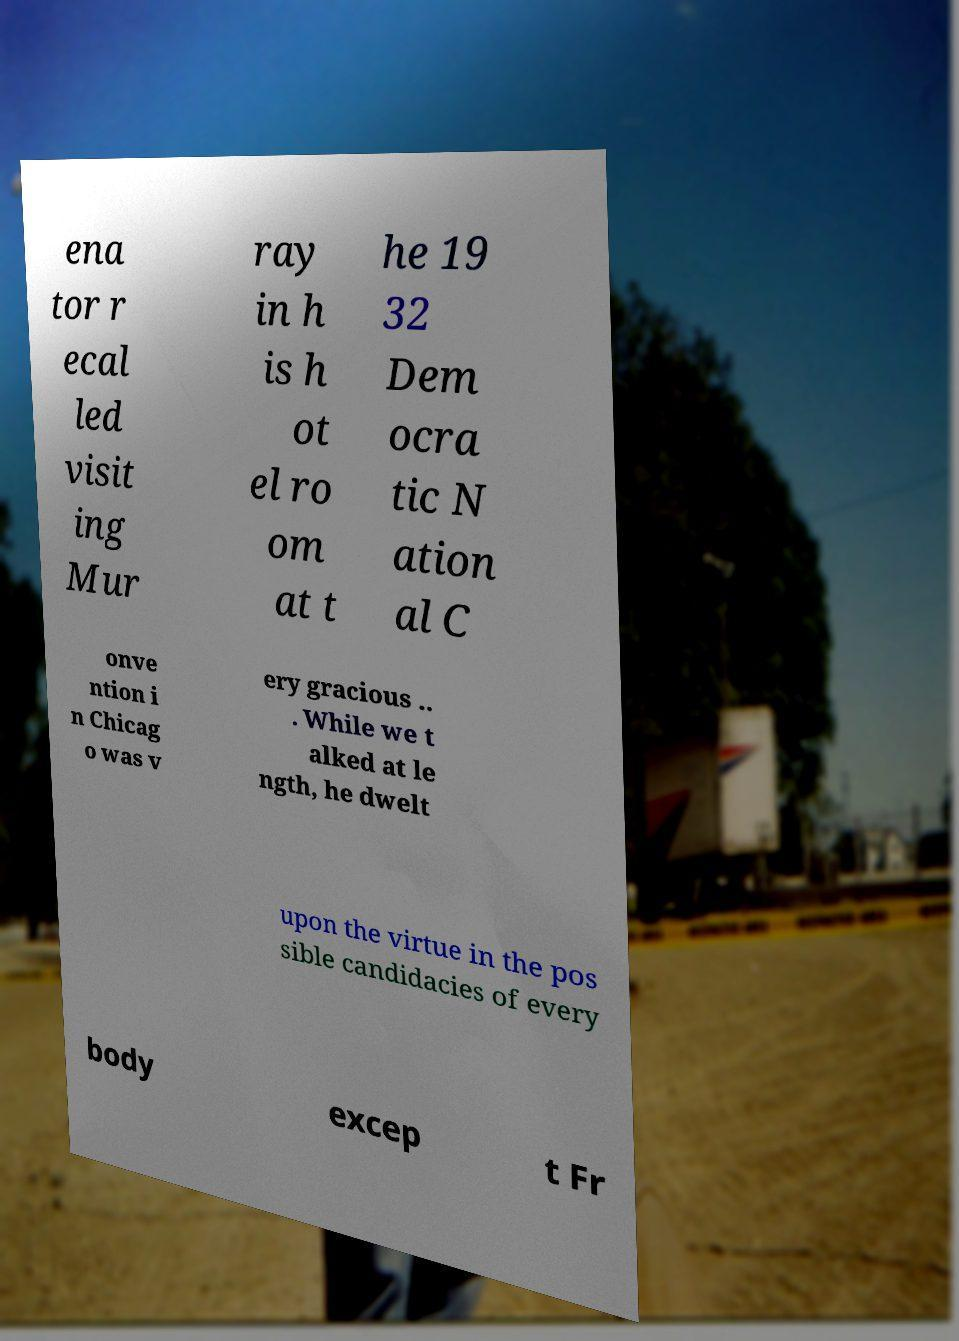For documentation purposes, I need the text within this image transcribed. Could you provide that? ena tor r ecal led visit ing Mur ray in h is h ot el ro om at t he 19 32 Dem ocra tic N ation al C onve ntion i n Chicag o was v ery gracious .. . While we t alked at le ngth, he dwelt upon the virtue in the pos sible candidacies of every body excep t Fr 